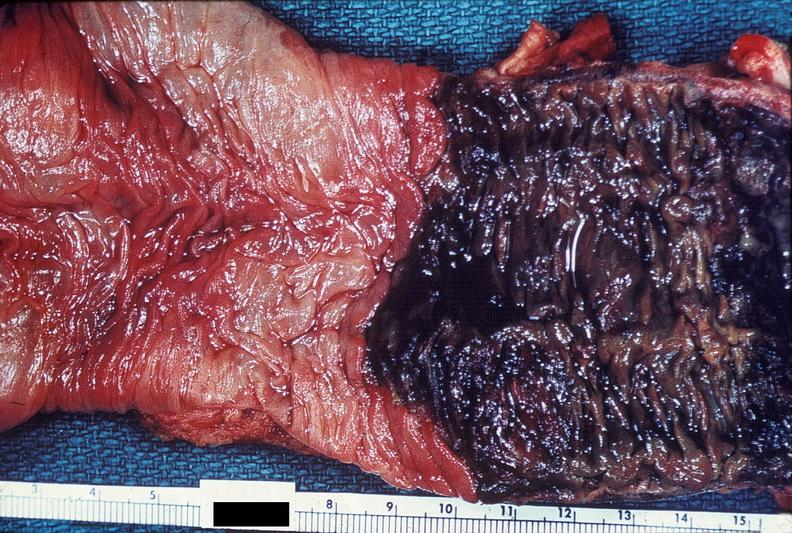does carcinoma metastatic lung show colon, ischemic colitis?
Answer the question using a single word or phrase. No 